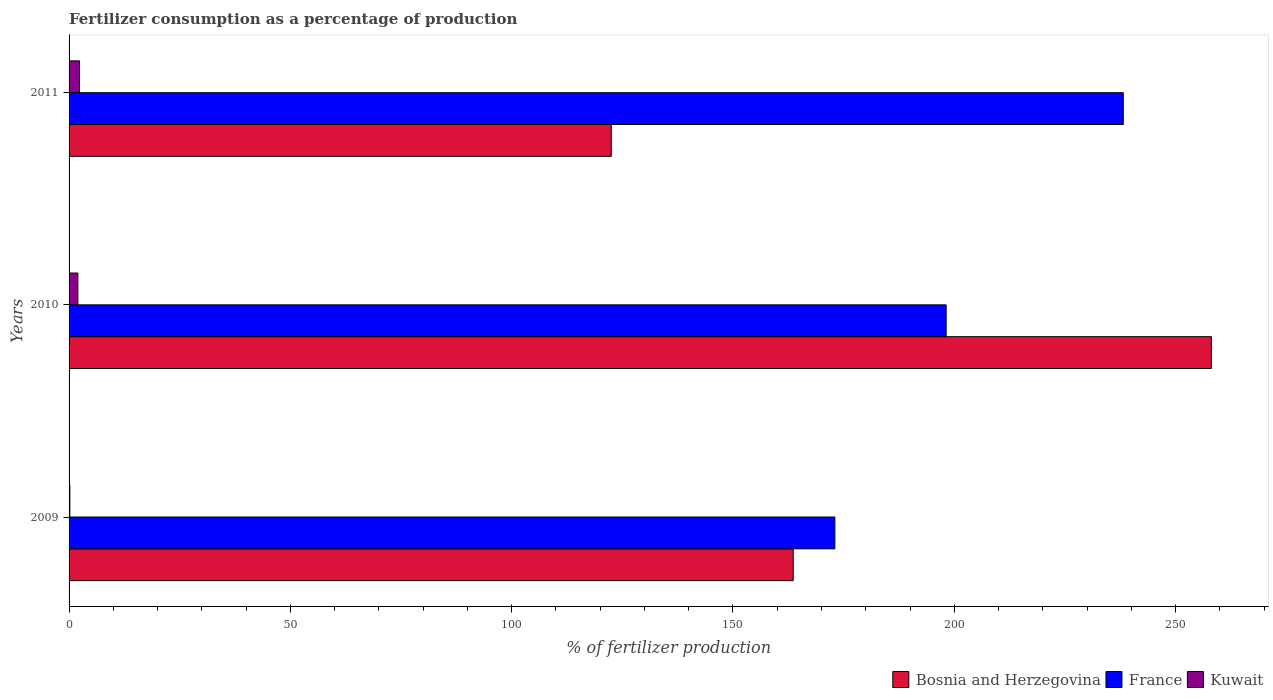How many groups of bars are there?
Provide a succinct answer. 3. Are the number of bars per tick equal to the number of legend labels?
Your response must be concise. Yes. Are the number of bars on each tick of the Y-axis equal?
Provide a succinct answer. Yes. How many bars are there on the 3rd tick from the top?
Your response must be concise. 3. How many bars are there on the 1st tick from the bottom?
Provide a short and direct response. 3. What is the label of the 3rd group of bars from the top?
Your answer should be very brief. 2009. What is the percentage of fertilizers consumed in France in 2011?
Your answer should be compact. 238.18. Across all years, what is the maximum percentage of fertilizers consumed in France?
Keep it short and to the point. 238.18. Across all years, what is the minimum percentage of fertilizers consumed in France?
Keep it short and to the point. 173.02. What is the total percentage of fertilizers consumed in Bosnia and Herzegovina in the graph?
Your answer should be very brief. 544.19. What is the difference between the percentage of fertilizers consumed in France in 2010 and that in 2011?
Keep it short and to the point. -40.02. What is the difference between the percentage of fertilizers consumed in Kuwait in 2010 and the percentage of fertilizers consumed in France in 2011?
Offer a terse response. -236.19. What is the average percentage of fertilizers consumed in Kuwait per year?
Keep it short and to the point. 1.51. In the year 2009, what is the difference between the percentage of fertilizers consumed in Kuwait and percentage of fertilizers consumed in France?
Make the answer very short. -172.84. What is the ratio of the percentage of fertilizers consumed in France in 2009 to that in 2011?
Offer a very short reply. 0.73. What is the difference between the highest and the second highest percentage of fertilizers consumed in France?
Offer a very short reply. 40.02. What is the difference between the highest and the lowest percentage of fertilizers consumed in Kuwait?
Make the answer very short. 2.17. In how many years, is the percentage of fertilizers consumed in France greater than the average percentage of fertilizers consumed in France taken over all years?
Make the answer very short. 1. Is the sum of the percentage of fertilizers consumed in France in 2009 and 2011 greater than the maximum percentage of fertilizers consumed in Bosnia and Herzegovina across all years?
Keep it short and to the point. Yes. What does the 3rd bar from the top in 2009 represents?
Keep it short and to the point. Bosnia and Herzegovina. What does the 1st bar from the bottom in 2009 represents?
Provide a short and direct response. Bosnia and Herzegovina. Are all the bars in the graph horizontal?
Provide a short and direct response. Yes. Are the values on the major ticks of X-axis written in scientific E-notation?
Provide a succinct answer. No. Does the graph contain any zero values?
Offer a very short reply. No. Does the graph contain grids?
Make the answer very short. No. Where does the legend appear in the graph?
Your answer should be very brief. Bottom right. How many legend labels are there?
Provide a succinct answer. 3. What is the title of the graph?
Your response must be concise. Fertilizer consumption as a percentage of production. Does "Hong Kong" appear as one of the legend labels in the graph?
Your response must be concise. No. What is the label or title of the X-axis?
Provide a short and direct response. % of fertilizer production. What is the label or title of the Y-axis?
Make the answer very short. Years. What is the % of fertilizer production of Bosnia and Herzegovina in 2009?
Ensure brevity in your answer.  163.61. What is the % of fertilizer production in France in 2009?
Ensure brevity in your answer.  173.02. What is the % of fertilizer production in Kuwait in 2009?
Your response must be concise. 0.18. What is the % of fertilizer production of Bosnia and Herzegovina in 2010?
Ensure brevity in your answer.  258.08. What is the % of fertilizer production in France in 2010?
Offer a very short reply. 198.16. What is the % of fertilizer production in Kuwait in 2010?
Keep it short and to the point. 1.99. What is the % of fertilizer production of Bosnia and Herzegovina in 2011?
Your answer should be compact. 122.5. What is the % of fertilizer production in France in 2011?
Make the answer very short. 238.18. What is the % of fertilizer production in Kuwait in 2011?
Offer a very short reply. 2.35. Across all years, what is the maximum % of fertilizer production in Bosnia and Herzegovina?
Offer a terse response. 258.08. Across all years, what is the maximum % of fertilizer production in France?
Keep it short and to the point. 238.18. Across all years, what is the maximum % of fertilizer production in Kuwait?
Your response must be concise. 2.35. Across all years, what is the minimum % of fertilizer production in Bosnia and Herzegovina?
Provide a succinct answer. 122.5. Across all years, what is the minimum % of fertilizer production in France?
Give a very brief answer. 173.02. Across all years, what is the minimum % of fertilizer production of Kuwait?
Provide a succinct answer. 0.18. What is the total % of fertilizer production in Bosnia and Herzegovina in the graph?
Give a very brief answer. 544.19. What is the total % of fertilizer production of France in the graph?
Your answer should be compact. 609.35. What is the total % of fertilizer production in Kuwait in the graph?
Offer a terse response. 4.52. What is the difference between the % of fertilizer production of Bosnia and Herzegovina in 2009 and that in 2010?
Make the answer very short. -94.48. What is the difference between the % of fertilizer production of France in 2009 and that in 2010?
Provide a short and direct response. -25.15. What is the difference between the % of fertilizer production of Kuwait in 2009 and that in 2010?
Make the answer very short. -1.81. What is the difference between the % of fertilizer production in Bosnia and Herzegovina in 2009 and that in 2011?
Offer a terse response. 41.11. What is the difference between the % of fertilizer production in France in 2009 and that in 2011?
Provide a succinct answer. -65.16. What is the difference between the % of fertilizer production in Kuwait in 2009 and that in 2011?
Keep it short and to the point. -2.17. What is the difference between the % of fertilizer production of Bosnia and Herzegovina in 2010 and that in 2011?
Your response must be concise. 135.58. What is the difference between the % of fertilizer production in France in 2010 and that in 2011?
Provide a succinct answer. -40.02. What is the difference between the % of fertilizer production of Kuwait in 2010 and that in 2011?
Provide a short and direct response. -0.36. What is the difference between the % of fertilizer production of Bosnia and Herzegovina in 2009 and the % of fertilizer production of France in 2010?
Provide a short and direct response. -34.55. What is the difference between the % of fertilizer production in Bosnia and Herzegovina in 2009 and the % of fertilizer production in Kuwait in 2010?
Provide a short and direct response. 161.62. What is the difference between the % of fertilizer production of France in 2009 and the % of fertilizer production of Kuwait in 2010?
Ensure brevity in your answer.  171.02. What is the difference between the % of fertilizer production in Bosnia and Herzegovina in 2009 and the % of fertilizer production in France in 2011?
Give a very brief answer. -74.57. What is the difference between the % of fertilizer production in Bosnia and Herzegovina in 2009 and the % of fertilizer production in Kuwait in 2011?
Keep it short and to the point. 161.26. What is the difference between the % of fertilizer production in France in 2009 and the % of fertilizer production in Kuwait in 2011?
Provide a succinct answer. 170.67. What is the difference between the % of fertilizer production of Bosnia and Herzegovina in 2010 and the % of fertilizer production of France in 2011?
Your response must be concise. 19.9. What is the difference between the % of fertilizer production of Bosnia and Herzegovina in 2010 and the % of fertilizer production of Kuwait in 2011?
Give a very brief answer. 255.74. What is the difference between the % of fertilizer production in France in 2010 and the % of fertilizer production in Kuwait in 2011?
Your answer should be very brief. 195.81. What is the average % of fertilizer production in Bosnia and Herzegovina per year?
Keep it short and to the point. 181.4. What is the average % of fertilizer production in France per year?
Make the answer very short. 203.12. What is the average % of fertilizer production of Kuwait per year?
Offer a terse response. 1.51. In the year 2009, what is the difference between the % of fertilizer production in Bosnia and Herzegovina and % of fertilizer production in France?
Provide a succinct answer. -9.41. In the year 2009, what is the difference between the % of fertilizer production of Bosnia and Herzegovina and % of fertilizer production of Kuwait?
Your response must be concise. 163.43. In the year 2009, what is the difference between the % of fertilizer production in France and % of fertilizer production in Kuwait?
Provide a succinct answer. 172.84. In the year 2010, what is the difference between the % of fertilizer production of Bosnia and Herzegovina and % of fertilizer production of France?
Give a very brief answer. 59.92. In the year 2010, what is the difference between the % of fertilizer production of Bosnia and Herzegovina and % of fertilizer production of Kuwait?
Your answer should be very brief. 256.09. In the year 2010, what is the difference between the % of fertilizer production of France and % of fertilizer production of Kuwait?
Ensure brevity in your answer.  196.17. In the year 2011, what is the difference between the % of fertilizer production in Bosnia and Herzegovina and % of fertilizer production in France?
Make the answer very short. -115.68. In the year 2011, what is the difference between the % of fertilizer production of Bosnia and Herzegovina and % of fertilizer production of Kuwait?
Your answer should be very brief. 120.15. In the year 2011, what is the difference between the % of fertilizer production of France and % of fertilizer production of Kuwait?
Provide a short and direct response. 235.83. What is the ratio of the % of fertilizer production in Bosnia and Herzegovina in 2009 to that in 2010?
Offer a terse response. 0.63. What is the ratio of the % of fertilizer production in France in 2009 to that in 2010?
Make the answer very short. 0.87. What is the ratio of the % of fertilizer production of Kuwait in 2009 to that in 2010?
Provide a short and direct response. 0.09. What is the ratio of the % of fertilizer production in Bosnia and Herzegovina in 2009 to that in 2011?
Provide a succinct answer. 1.34. What is the ratio of the % of fertilizer production in France in 2009 to that in 2011?
Provide a short and direct response. 0.73. What is the ratio of the % of fertilizer production of Kuwait in 2009 to that in 2011?
Your answer should be compact. 0.08. What is the ratio of the % of fertilizer production in Bosnia and Herzegovina in 2010 to that in 2011?
Your answer should be compact. 2.11. What is the ratio of the % of fertilizer production in France in 2010 to that in 2011?
Offer a terse response. 0.83. What is the ratio of the % of fertilizer production in Kuwait in 2010 to that in 2011?
Your answer should be very brief. 0.85. What is the difference between the highest and the second highest % of fertilizer production of Bosnia and Herzegovina?
Offer a very short reply. 94.48. What is the difference between the highest and the second highest % of fertilizer production of France?
Provide a succinct answer. 40.02. What is the difference between the highest and the second highest % of fertilizer production in Kuwait?
Your answer should be compact. 0.36. What is the difference between the highest and the lowest % of fertilizer production of Bosnia and Herzegovina?
Give a very brief answer. 135.58. What is the difference between the highest and the lowest % of fertilizer production of France?
Offer a very short reply. 65.16. What is the difference between the highest and the lowest % of fertilizer production of Kuwait?
Your response must be concise. 2.17. 